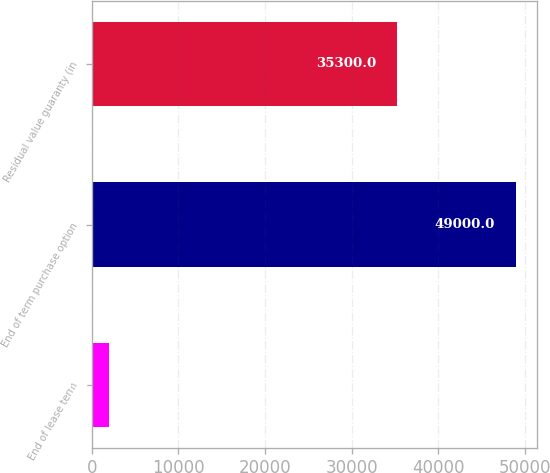Convert chart to OTSL. <chart><loc_0><loc_0><loc_500><loc_500><bar_chart><fcel>End of lease term<fcel>End of term purchase option<fcel>Residual value guaranty (in<nl><fcel>2011<fcel>49000<fcel>35300<nl></chart> 